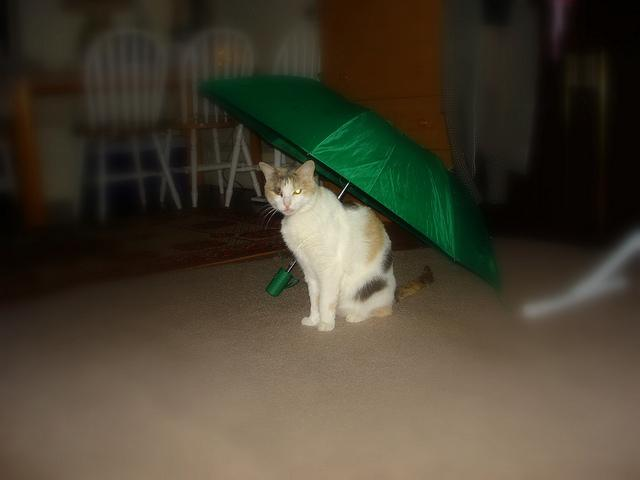What is the white object to the right of the cat likely to be? ironing board 